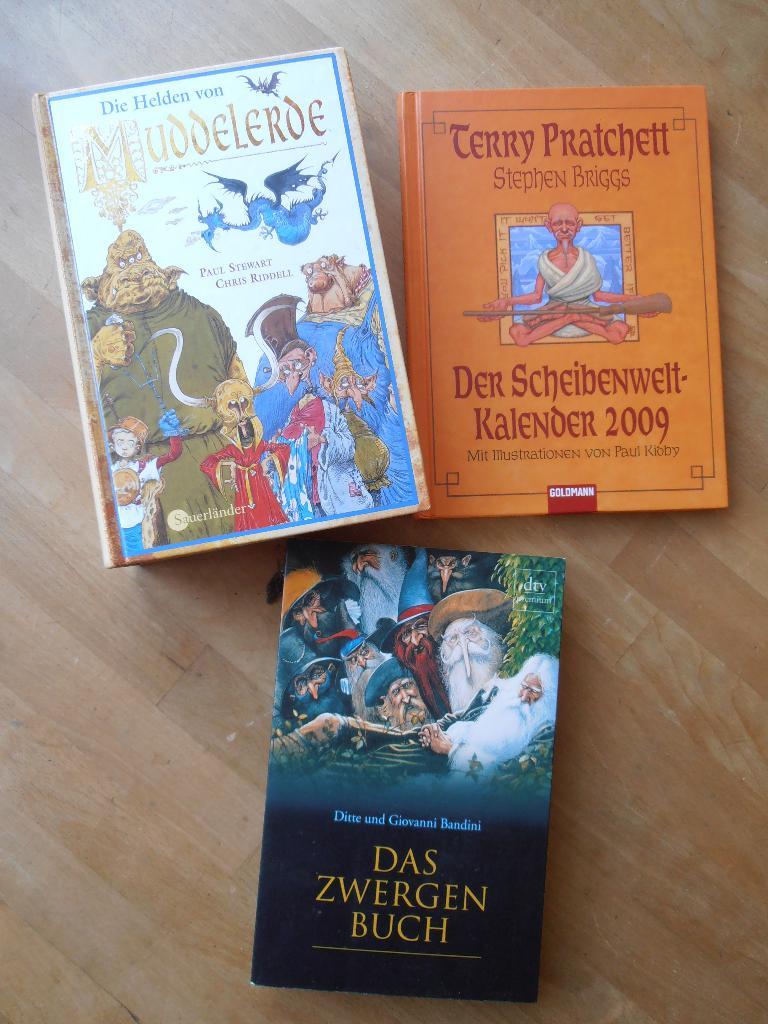What are the names of the three books?
Give a very brief answer. Muddelerde, der schelbenwell, das zwergen buch. Who wrote the top left book?
Keep it short and to the point. Paul stewart. 